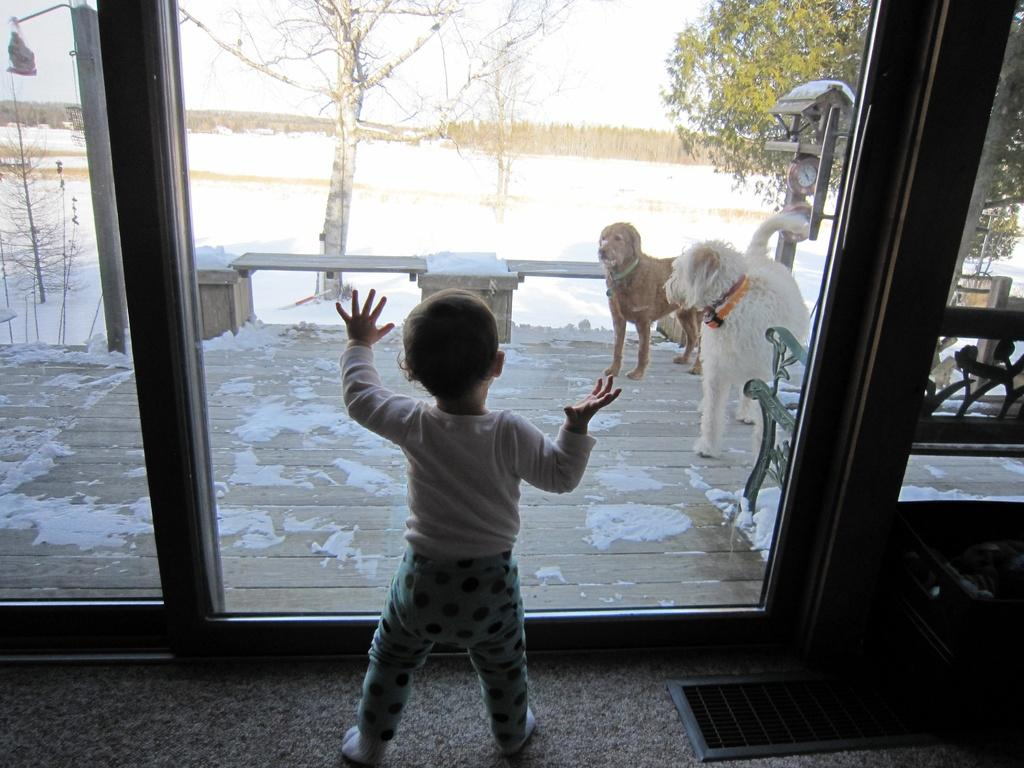What is the boy doing in the image? The boy is standing in front of a glass door. What can be seen through the glass door? Two dogs and trees are visible through the glass door. How are the trees in the image? The trees have snow on them. What degree does the boy have in the image? There is no indication of the boy's degree in the image. What hope does the boy have for the dogs in the image? There is no indication of the boy's hopes or intentions regarding the dogs in the image. 